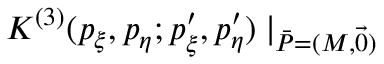Convert formula to latex. <formula><loc_0><loc_0><loc_500><loc_500>K ^ { ( 3 ) } ( p _ { \xi } , p _ { \eta } ; p _ { \xi } ^ { \prime } , p _ { \eta } ^ { \prime } ) | _ { \bar { P } = ( M , \vec { 0 } ) } \,</formula> 